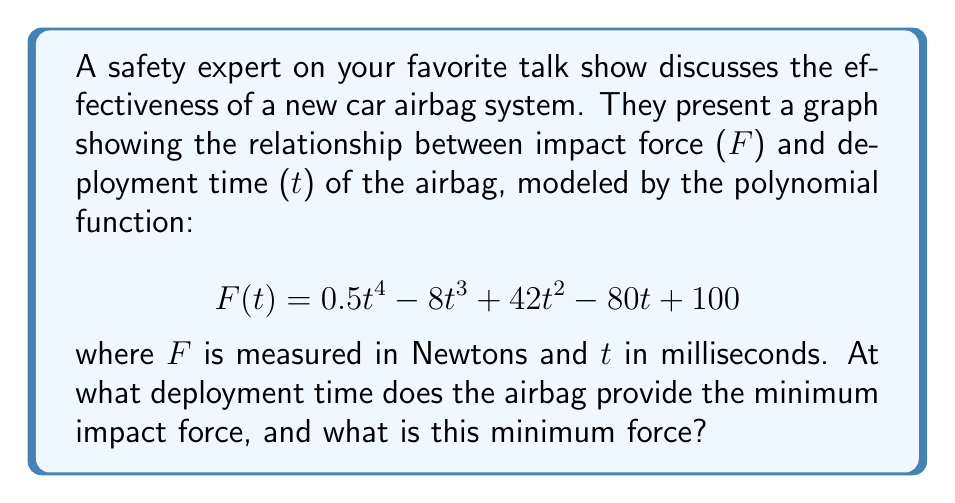Could you help me with this problem? To find the minimum impact force and its corresponding deployment time, we need to follow these steps:

1) Find the derivative of F(t):
   $$F'(t) = 2t^3 - 24t^2 + 84t - 80$$

2) Set the derivative equal to zero and solve for t:
   $$2t^3 - 24t^2 + 84t - 80 = 0$$

3) This cubic equation can be factored as:
   $$2(t - 2)(t^2 - 10t + 20) = 0$$

4) Solving this, we get t = 2, 5, or 5 (repeated root)

5) The second derivative is:
   $$F''(t) = 6t^2 - 48t + 84$$

6) Evaluate F''(t) at t = 2 and t = 5:
   F''(2) = 6(4) - 48(2) + 84 = 12 > 0
   F''(5) = 6(25) - 48(5) + 84 = 9 > 0

   Since both are positive, both t = 2 and t = 5 are local minima.

7) Evaluate F(t) at t = 2 and t = 5:
   F(2) = 0.5(16) - 8(8) + 42(4) - 80(2) + 100 = 36
   F(5) = 0.5(625) - 8(125) + 42(25) - 80(5) + 100 = 18.75

Therefore, the minimum impact force occurs at t = 5 ms with a force of 18.75 N.
Answer: 5 ms, 18.75 N 